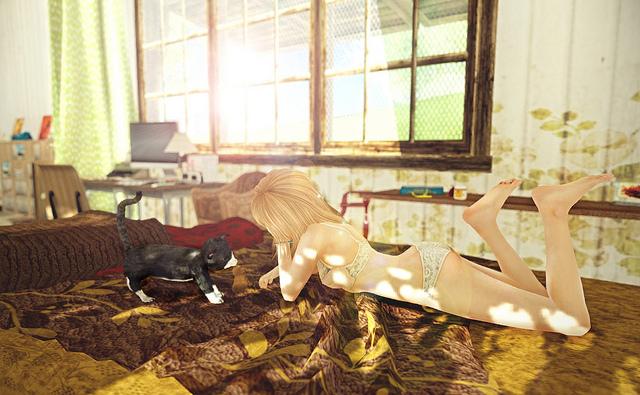Is the woman lying in sunlight?
Quick response, please. Yes. Does the cat have hair?
Concise answer only. Yes. What is the woman wearing?
Be succinct. Bra and panties. Is this a painting or a photograph?
Be succinct. Painting. 